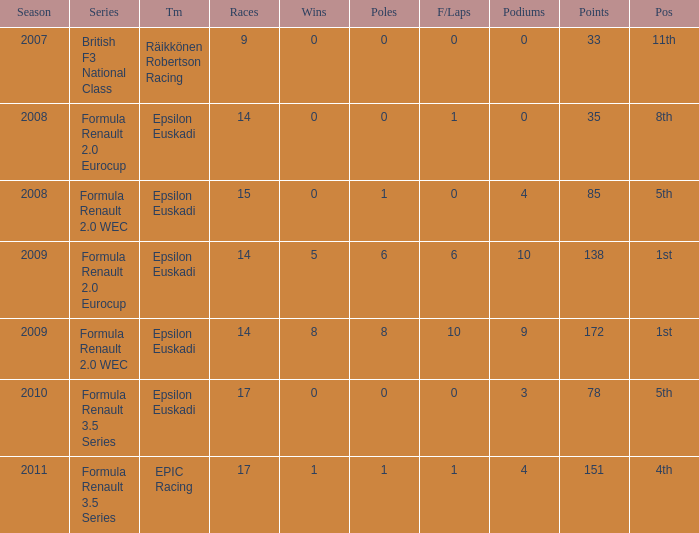What team was he on when he had 10 f/laps? Epsilon Euskadi. 